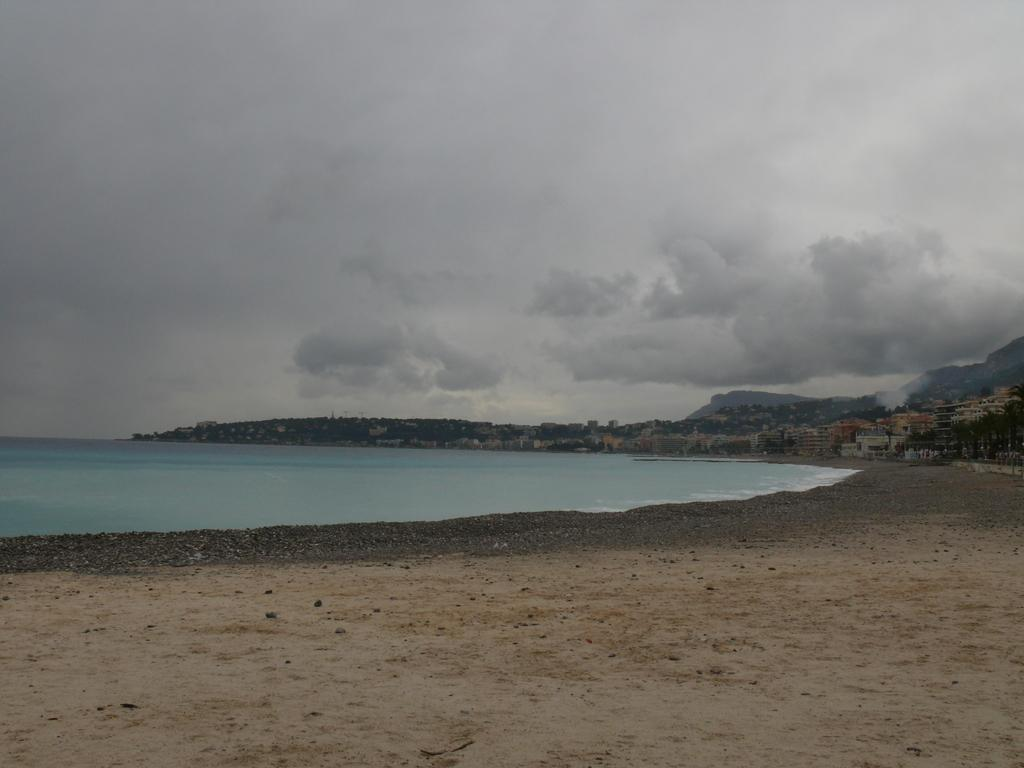What type of structures can be seen in the image? There are buildings in the image. What other natural elements are present in the image? There are trees and hills visible in the image. What can be seen at the bottom of the image? There is water and ground visible at the bottom of the image. What is visible in the sky at the top of the image? There are clouds in the sky at the top of the image. Who is the porter in the image? There is no porter present in the image. What suggestion is being made by the clouds in the image? The clouds in the image are not making any suggestions; they are simply visible in the sky. 